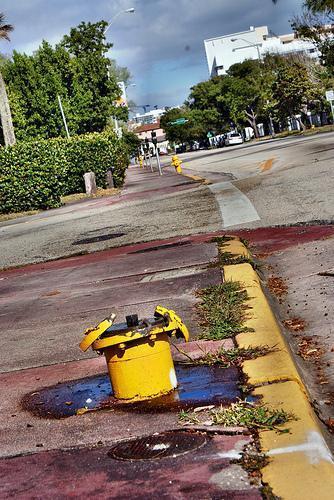How many hydrants are there?
Give a very brief answer. 1. 